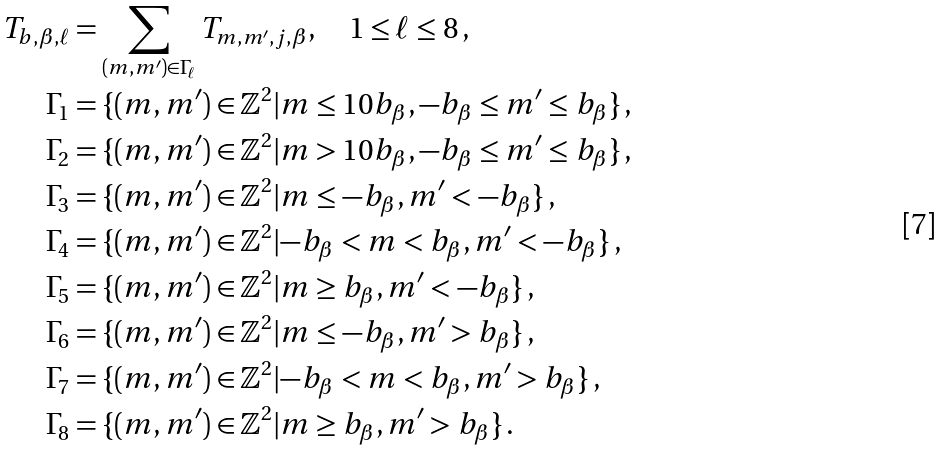<formula> <loc_0><loc_0><loc_500><loc_500>T _ { b , \beta , \ell } & = \sum _ { ( m , m ^ { \prime } ) \in \Gamma _ { \ell } } T _ { m , m ^ { \prime } , j , \beta } , \quad 1 \leq \ell \leq 8 \, , \\ \Gamma _ { 1 } & = \{ ( m , m ^ { \prime } ) \in \mathbb { Z } ^ { 2 } | { m \leq 1 0 b _ { \beta } , - b _ { \beta } \leq m ^ { \prime } \leq b _ { \beta } } \} \, , \\ \Gamma _ { 2 } & = \{ ( m , m ^ { \prime } ) \in \mathbb { Z } ^ { 2 } | { m > 1 0 b _ { \beta } , - b _ { \beta } \leq m ^ { \prime } \leq b _ { \beta } } \} \, , \\ \Gamma _ { 3 } & = \{ ( m , m ^ { \prime } ) \in \mathbb { Z } ^ { 2 } | { m \leq - b _ { \beta } , m ^ { \prime } < - b _ { \beta } } \} \, , \\ \Gamma _ { 4 } & = \{ ( m , m ^ { \prime } ) \in \mathbb { Z } ^ { 2 } | { - b _ { \beta } < m < b _ { \beta } , m ^ { \prime } < - b _ { \beta } } \} \, , \\ \Gamma _ { 5 } & = \{ ( m , m ^ { \prime } ) \in \mathbb { Z } ^ { 2 } | { m \geq b _ { \beta } , m ^ { \prime } < - b _ { \beta } } \} \, , \\ \Gamma _ { 6 } & = \{ ( m , m ^ { \prime } ) \in \mathbb { Z } ^ { 2 } | { m \leq - b _ { \beta } , m ^ { \prime } > b _ { \beta } } \} \, , \\ \Gamma _ { 7 } & = \{ ( m , m ^ { \prime } ) \in \mathbb { Z } ^ { 2 } | { - b _ { \beta } < m < b _ { \beta } , m ^ { \prime } > b _ { \beta } } \} \, , \\ \Gamma _ { 8 } & = \{ ( m , m ^ { \prime } ) \in \mathbb { Z } ^ { 2 } | { m \geq b _ { \beta } , m ^ { \prime } > b _ { \beta } } \} \, .</formula> 